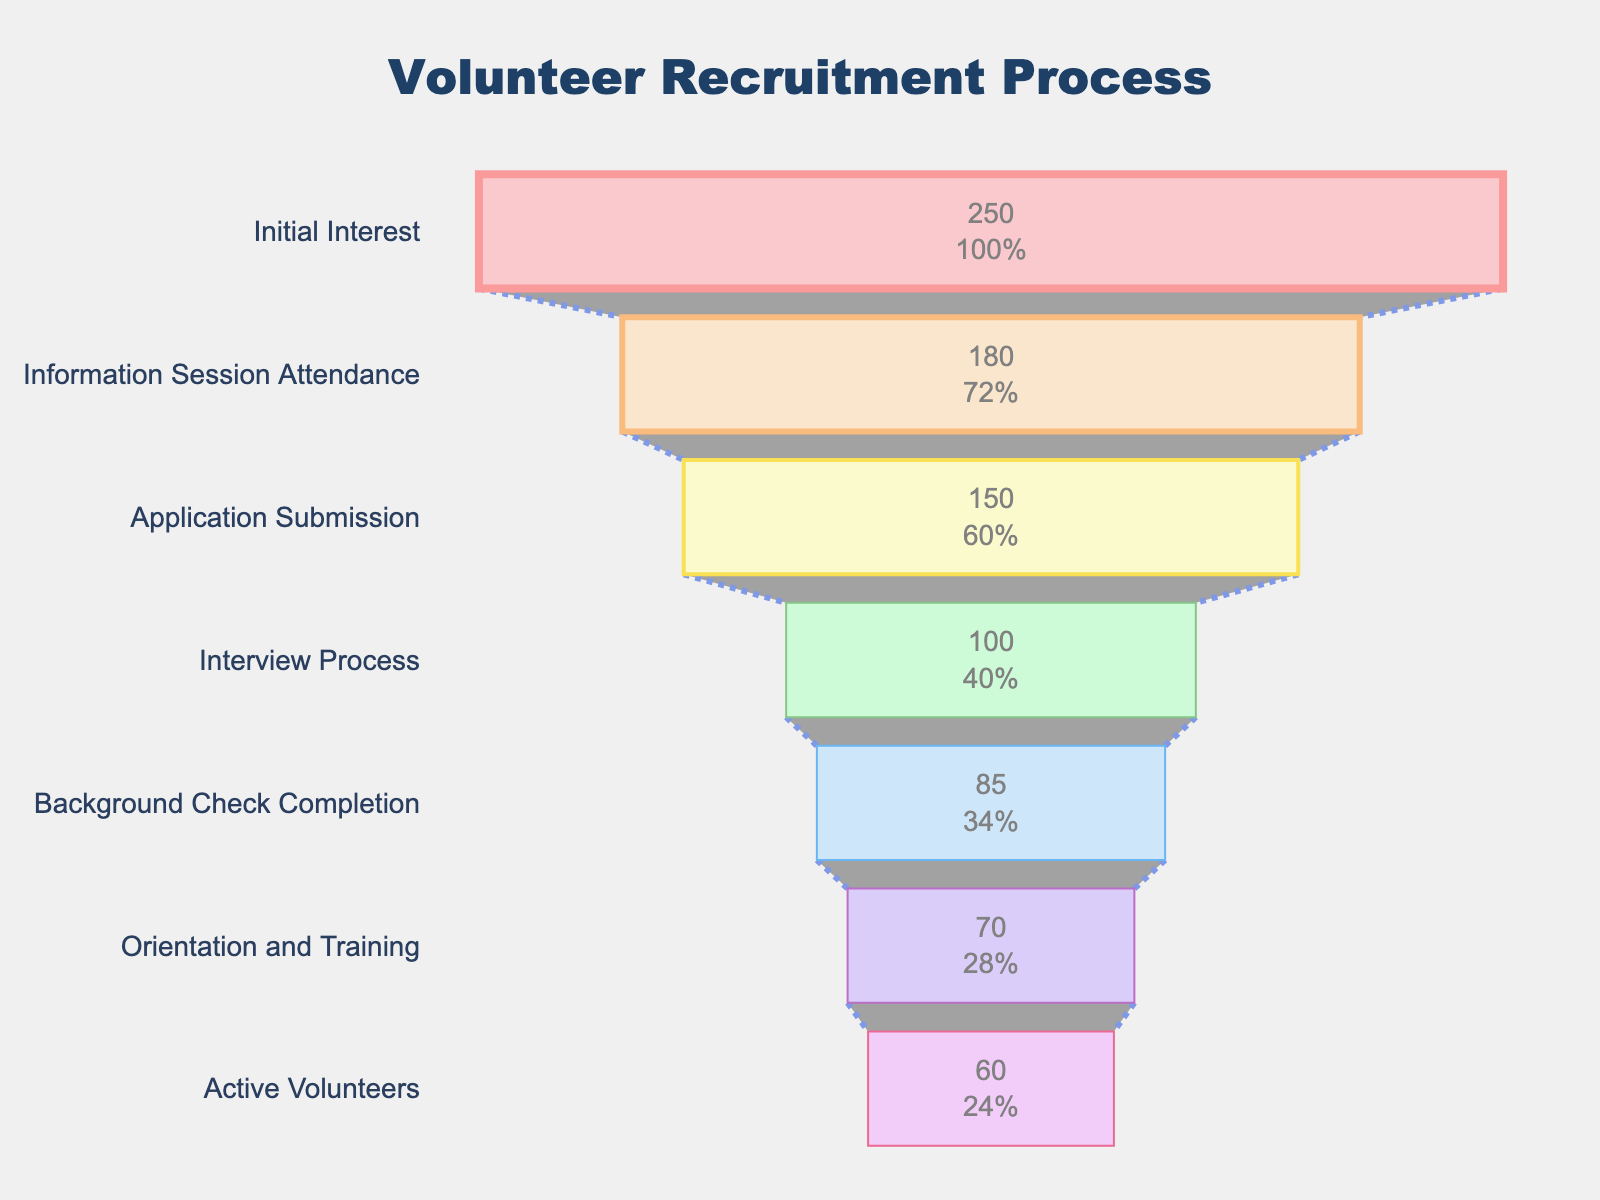What is the title of the funnel chart? The title of the funnel chart is found at the top center of the chart. It reads "Volunteer Recruitment Process".
Answer: Volunteer Recruitment Process How many stages are there in the volunteer recruitment process? The funnel chart lists multiple stages. Counting each stage listed gives a total number.
Answer: 7 What is the percentage of participants who attended the information session out of those who showed initial interest? To find the percentage, divide the number who attended the information session (180) by the initial interest (250) and multiply by 100. \( \frac{180}{250} \times 100 = 72\% \)
Answer: 72% By how much did the number of participants drop from the interview process to the background check completion? Subtract the number of participants in the background check completion (85) from the interview process (100). \( 100 - 85 = 15 \)
Answer: 15 Which stage saw the greatest drop in the number of participants compared to the previous stage? Compare the difference in participants between consecutive stages and find the maximum drop.
Answer: Initial Interest to Information Session Attendance What proportion of the initial interested participants became active volunteers? Divide the number of active volunteers (60) by the initial interest (250) and multiply by 100. \( \frac{60}{250} \times 100 = 24\% \)
Answer: 24% Which stage has the fewest participants? Look at the stages and identify which one has the lowest number of participants.
Answer: Active Volunteers How many more participants completed the orientation and training compared to the background check? Subtract the number of participants in the background check completion (85) from the orientation and training (70). \( 85 - 70 = 15 \)
Answer: 15 At what stage does the process result in participants becoming active volunteers? Identify the last stage listed in the funnel chart where participants are classified as active volunteers.
Answer: Active Volunteers What is the average number of participants from the application submission to the orientation and training stage? Add the number of participants for the stages (150 for Application Submission, 100 for Interview Process, 85 for Background Check Completion, 70 for Orientation and Training) and divide by 4. \( \frac{150 + 100 + 85 + 70}{4} = 101.25 \)
Answer: 101.25 